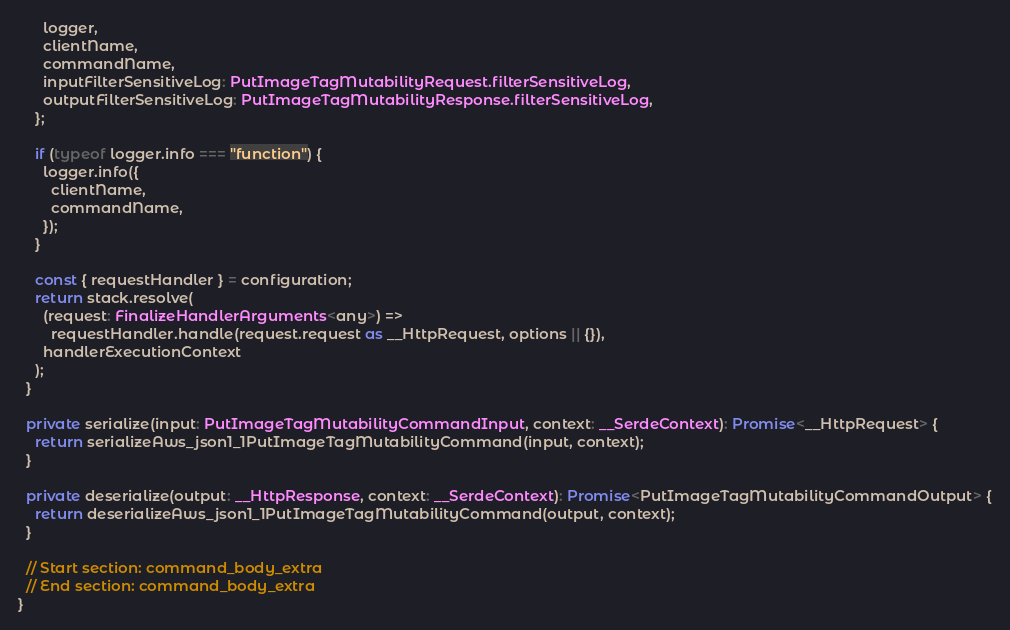Convert code to text. <code><loc_0><loc_0><loc_500><loc_500><_TypeScript_>      logger,
      clientName,
      commandName,
      inputFilterSensitiveLog: PutImageTagMutabilityRequest.filterSensitiveLog,
      outputFilterSensitiveLog: PutImageTagMutabilityResponse.filterSensitiveLog,
    };

    if (typeof logger.info === "function") {
      logger.info({
        clientName,
        commandName,
      });
    }

    const { requestHandler } = configuration;
    return stack.resolve(
      (request: FinalizeHandlerArguments<any>) =>
        requestHandler.handle(request.request as __HttpRequest, options || {}),
      handlerExecutionContext
    );
  }

  private serialize(input: PutImageTagMutabilityCommandInput, context: __SerdeContext): Promise<__HttpRequest> {
    return serializeAws_json1_1PutImageTagMutabilityCommand(input, context);
  }

  private deserialize(output: __HttpResponse, context: __SerdeContext): Promise<PutImageTagMutabilityCommandOutput> {
    return deserializeAws_json1_1PutImageTagMutabilityCommand(output, context);
  }

  // Start section: command_body_extra
  // End section: command_body_extra
}
</code> 